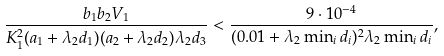<formula> <loc_0><loc_0><loc_500><loc_500>\frac { b _ { 1 } b _ { 2 } V _ { 1 } } { K _ { 1 } ^ { 2 } ( a _ { 1 } + \lambda _ { 2 } d _ { 1 } ) ( a _ { 2 } + \lambda _ { 2 } d _ { 2 } ) \lambda _ { 2 } d _ { 3 } } < \frac { 9 \cdot 1 0 ^ { - 4 } } { ( 0 . 0 1 + \lambda _ { 2 } \min _ { i } { d _ { i } } ) ^ { 2 } \lambda _ { 2 } \min _ { i } { d _ { i } } } ,</formula> 